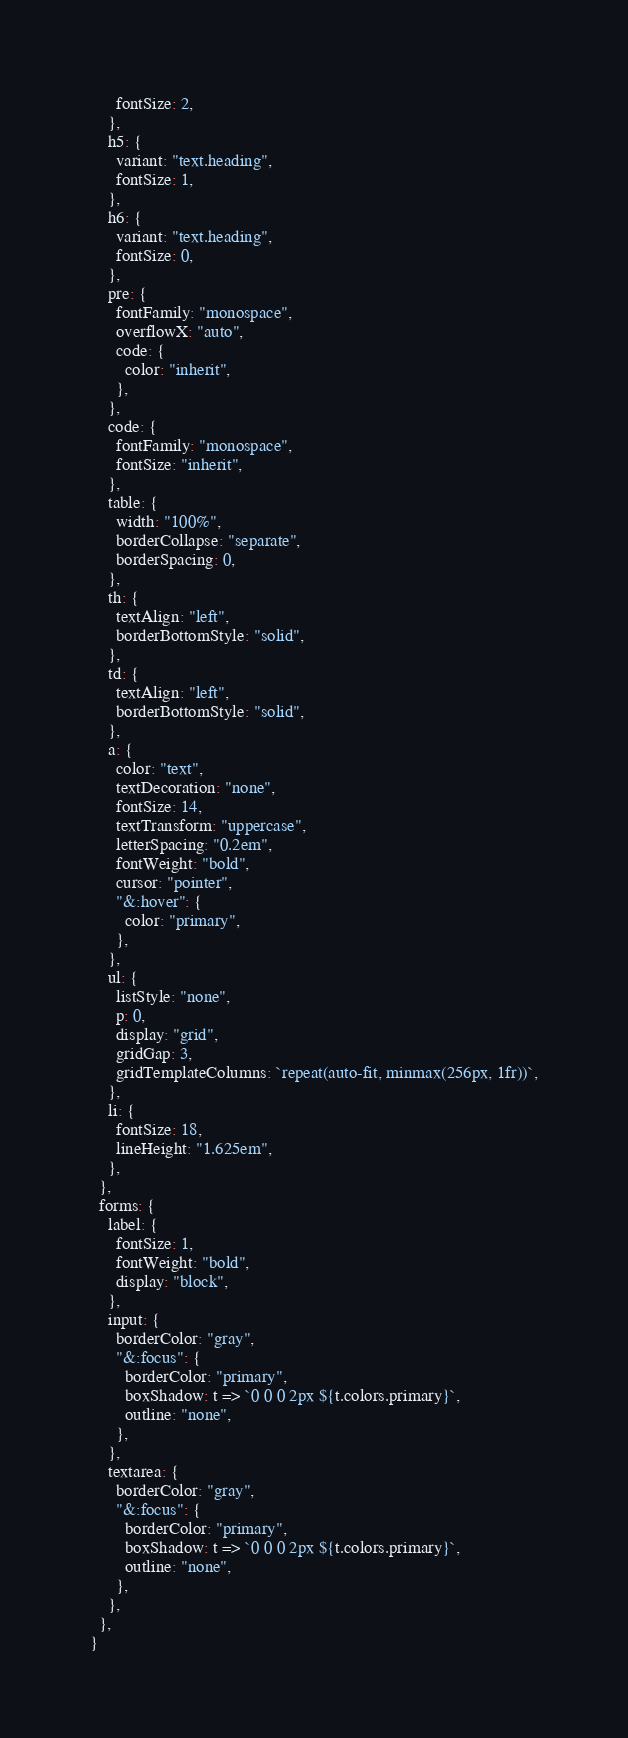Convert code to text. <code><loc_0><loc_0><loc_500><loc_500><_JavaScript_>      fontSize: 2,
    },
    h5: {
      variant: "text.heading",
      fontSize: 1,
    },
    h6: {
      variant: "text.heading",
      fontSize: 0,
    },
    pre: {
      fontFamily: "monospace",
      overflowX: "auto",
      code: {
        color: "inherit",
      },
    },
    code: {
      fontFamily: "monospace",
      fontSize: "inherit",
    },
    table: {
      width: "100%",
      borderCollapse: "separate",
      borderSpacing: 0,
    },
    th: {
      textAlign: "left",
      borderBottomStyle: "solid",
    },
    td: {
      textAlign: "left",
      borderBottomStyle: "solid",
    },
    a: {
      color: "text",
      textDecoration: "none",
      fontSize: 14,
      textTransform: "uppercase",
      letterSpacing: "0.2em",
      fontWeight: "bold",
      cursor: "pointer",
      "&:hover": {
        color: "primary",
      },
    },
    ul: {
      listStyle: "none",
      p: 0,
      display: "grid",
      gridGap: 3,
      gridTemplateColumns: `repeat(auto-fit, minmax(256px, 1fr))`,
    },
    li: {
      fontSize: 18,
      lineHeight: "1.625em",
    },
  },
  forms: {
    label: {
      fontSize: 1,
      fontWeight: "bold",
      display: "block",
    },
    input: {
      borderColor: "gray",
      "&:focus": {
        borderColor: "primary",
        boxShadow: t => `0 0 0 2px ${t.colors.primary}`,
        outline: "none",
      },
    },
    textarea: {
      borderColor: "gray",
      "&:focus": {
        borderColor: "primary",
        boxShadow: t => `0 0 0 2px ${t.colors.primary}`,
        outline: "none",
      },
    },
  },
}
</code> 